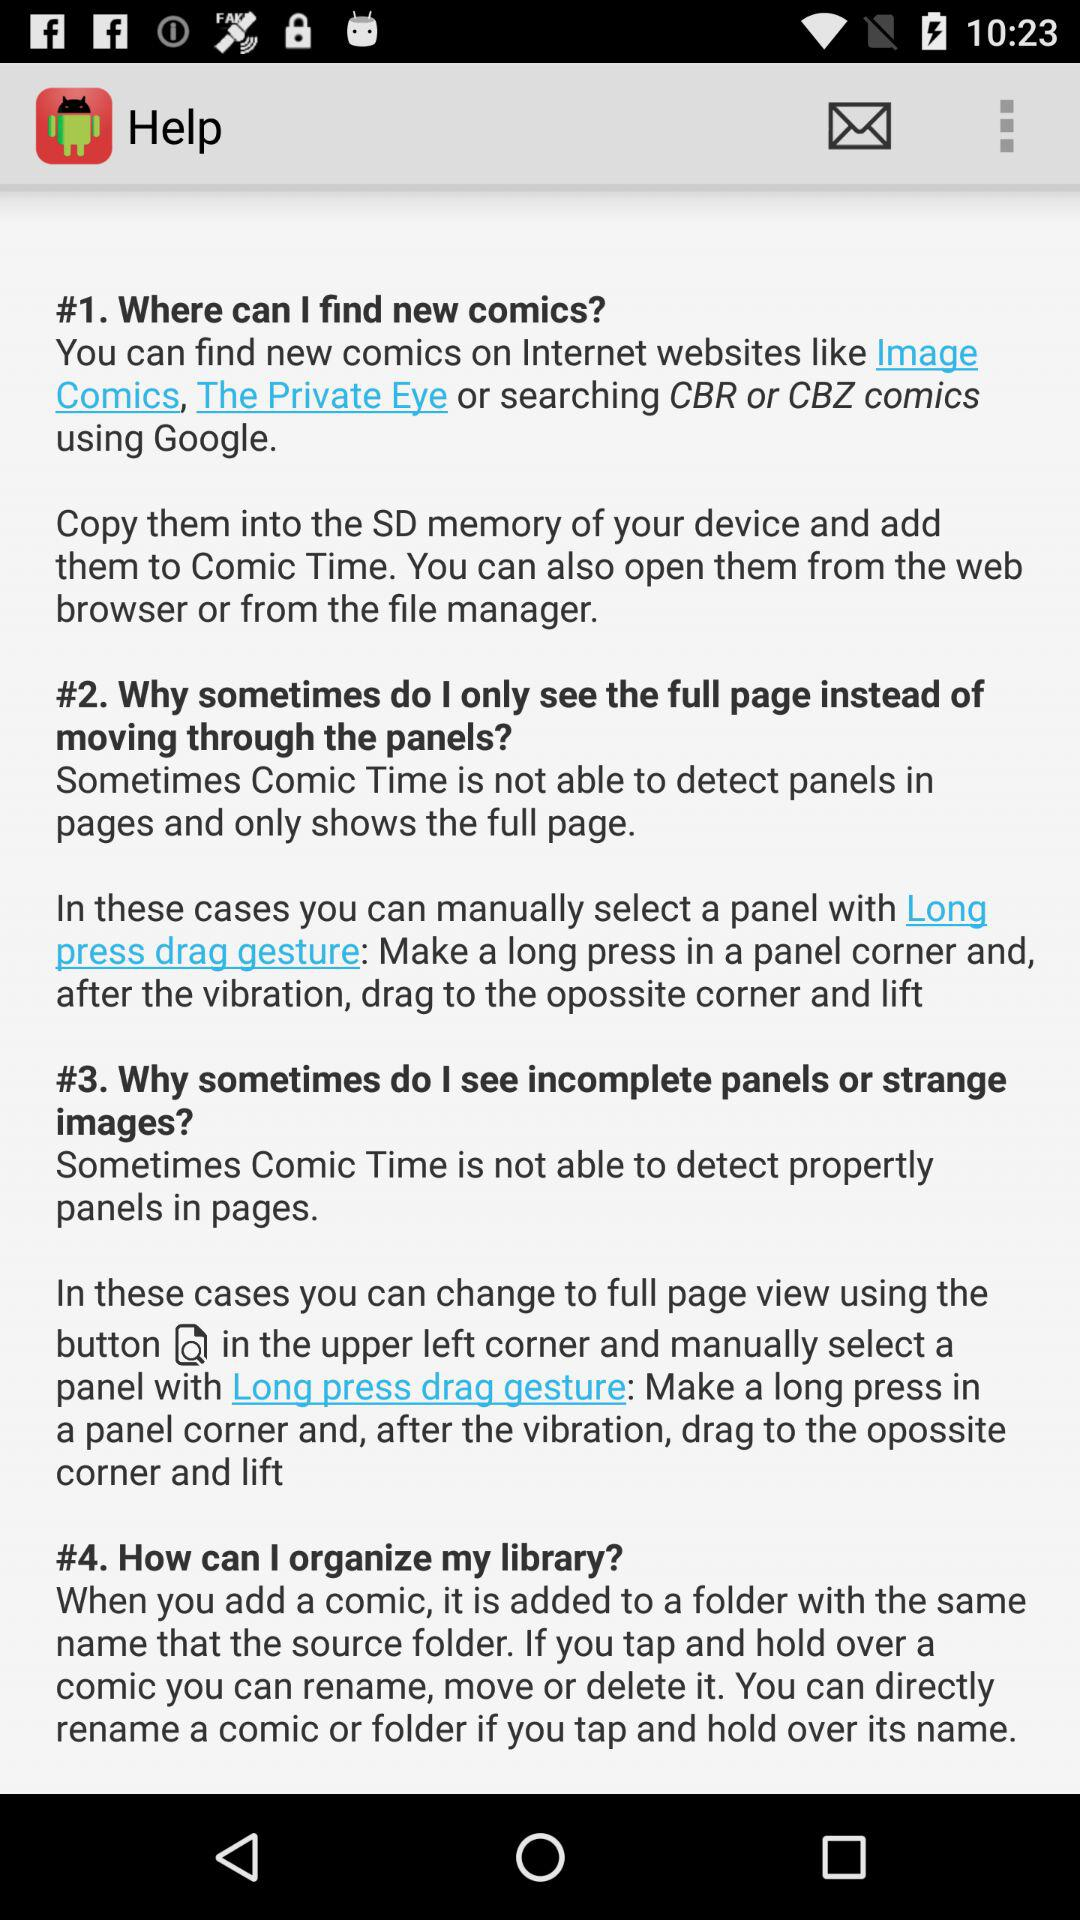How many different ways can I find new comics?
Answer the question using a single word or phrase. 3 